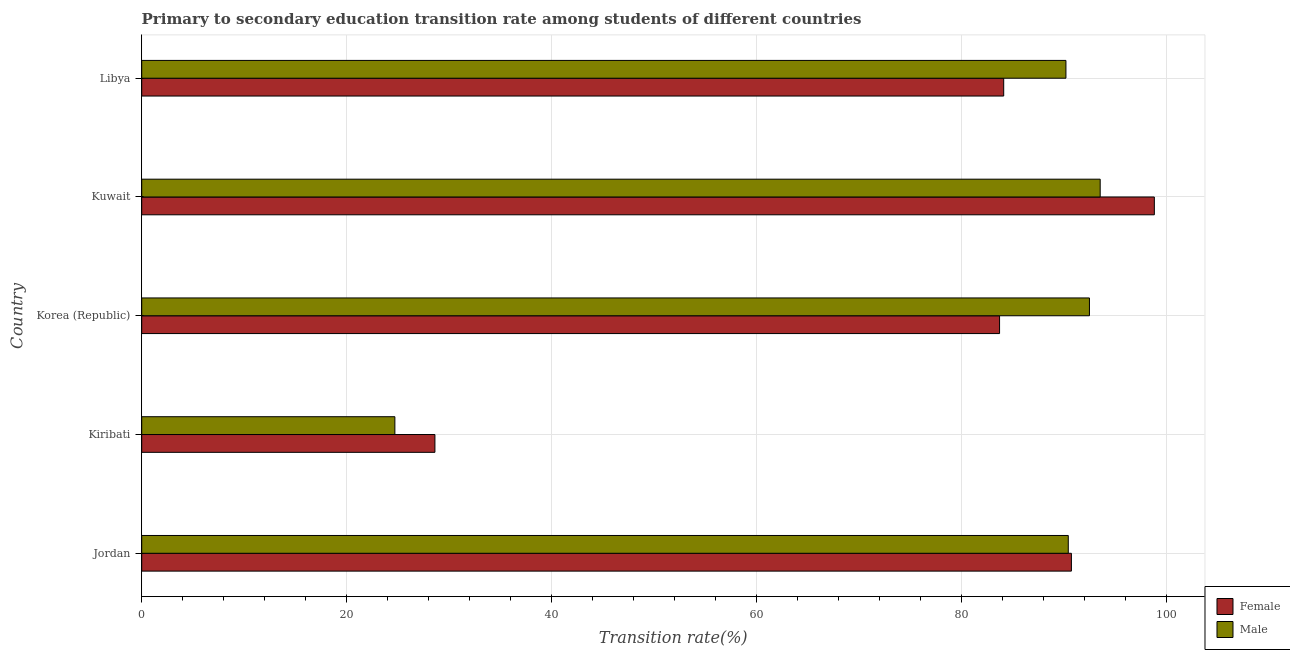How many groups of bars are there?
Make the answer very short. 5. How many bars are there on the 2nd tick from the top?
Offer a very short reply. 2. How many bars are there on the 3rd tick from the bottom?
Your response must be concise. 2. What is the label of the 1st group of bars from the top?
Give a very brief answer. Libya. In how many cases, is the number of bars for a given country not equal to the number of legend labels?
Offer a very short reply. 0. What is the transition rate among female students in Kuwait?
Offer a very short reply. 98.77. Across all countries, what is the maximum transition rate among female students?
Provide a succinct answer. 98.77. Across all countries, what is the minimum transition rate among female students?
Your answer should be compact. 28.6. In which country was the transition rate among female students maximum?
Give a very brief answer. Kuwait. In which country was the transition rate among male students minimum?
Ensure brevity in your answer.  Kiribati. What is the total transition rate among female students in the graph?
Your response must be concise. 385.8. What is the difference between the transition rate among female students in Kuwait and that in Libya?
Provide a short and direct response. 14.69. What is the difference between the transition rate among male students in Libya and the transition rate among female students in Jordan?
Keep it short and to the point. -0.53. What is the average transition rate among female students per country?
Your response must be concise. 77.16. What is the difference between the transition rate among female students and transition rate among male students in Kiribati?
Make the answer very short. 3.91. Is the difference between the transition rate among female students in Jordan and Korea (Republic) greater than the difference between the transition rate among male students in Jordan and Korea (Republic)?
Provide a short and direct response. Yes. What is the difference between the highest and the second highest transition rate among female students?
Keep it short and to the point. 8.09. What is the difference between the highest and the lowest transition rate among male students?
Ensure brevity in your answer.  68.8. How many countries are there in the graph?
Your answer should be compact. 5. What is the difference between two consecutive major ticks on the X-axis?
Your answer should be very brief. 20. Are the values on the major ticks of X-axis written in scientific E-notation?
Provide a succinct answer. No. Where does the legend appear in the graph?
Offer a terse response. Bottom right. How many legend labels are there?
Make the answer very short. 2. What is the title of the graph?
Give a very brief answer. Primary to secondary education transition rate among students of different countries. Does "Under-five" appear as one of the legend labels in the graph?
Keep it short and to the point. No. What is the label or title of the X-axis?
Provide a succinct answer. Transition rate(%). What is the Transition rate(%) of Female in Jordan?
Your answer should be compact. 90.68. What is the Transition rate(%) in Male in Jordan?
Your answer should be very brief. 90.37. What is the Transition rate(%) of Female in Kiribati?
Make the answer very short. 28.6. What is the Transition rate(%) of Male in Kiribati?
Keep it short and to the point. 24.69. What is the Transition rate(%) in Female in Korea (Republic)?
Make the answer very short. 83.67. What is the Transition rate(%) of Male in Korea (Republic)?
Offer a very short reply. 92.44. What is the Transition rate(%) in Female in Kuwait?
Provide a succinct answer. 98.77. What is the Transition rate(%) of Male in Kuwait?
Ensure brevity in your answer.  93.49. What is the Transition rate(%) of Female in Libya?
Your response must be concise. 84.08. What is the Transition rate(%) in Male in Libya?
Offer a very short reply. 90.15. Across all countries, what is the maximum Transition rate(%) in Female?
Ensure brevity in your answer.  98.77. Across all countries, what is the maximum Transition rate(%) in Male?
Your response must be concise. 93.49. Across all countries, what is the minimum Transition rate(%) in Female?
Your response must be concise. 28.6. Across all countries, what is the minimum Transition rate(%) in Male?
Your answer should be very brief. 24.69. What is the total Transition rate(%) of Female in the graph?
Give a very brief answer. 385.8. What is the total Transition rate(%) in Male in the graph?
Your answer should be very brief. 391.14. What is the difference between the Transition rate(%) in Female in Jordan and that in Kiribati?
Offer a very short reply. 62.08. What is the difference between the Transition rate(%) of Male in Jordan and that in Kiribati?
Your response must be concise. 65.68. What is the difference between the Transition rate(%) in Female in Jordan and that in Korea (Republic)?
Give a very brief answer. 7.01. What is the difference between the Transition rate(%) of Male in Jordan and that in Korea (Republic)?
Give a very brief answer. -2.07. What is the difference between the Transition rate(%) of Female in Jordan and that in Kuwait?
Your answer should be very brief. -8.09. What is the difference between the Transition rate(%) in Male in Jordan and that in Kuwait?
Offer a terse response. -3.11. What is the difference between the Transition rate(%) in Female in Jordan and that in Libya?
Your answer should be very brief. 6.6. What is the difference between the Transition rate(%) of Male in Jordan and that in Libya?
Ensure brevity in your answer.  0.23. What is the difference between the Transition rate(%) of Female in Kiribati and that in Korea (Republic)?
Offer a very short reply. -55.07. What is the difference between the Transition rate(%) in Male in Kiribati and that in Korea (Republic)?
Provide a short and direct response. -67.75. What is the difference between the Transition rate(%) of Female in Kiribati and that in Kuwait?
Keep it short and to the point. -70.17. What is the difference between the Transition rate(%) of Male in Kiribati and that in Kuwait?
Ensure brevity in your answer.  -68.8. What is the difference between the Transition rate(%) in Female in Kiribati and that in Libya?
Your answer should be compact. -55.48. What is the difference between the Transition rate(%) of Male in Kiribati and that in Libya?
Provide a short and direct response. -65.45. What is the difference between the Transition rate(%) in Female in Korea (Republic) and that in Kuwait?
Offer a very short reply. -15.1. What is the difference between the Transition rate(%) in Male in Korea (Republic) and that in Kuwait?
Ensure brevity in your answer.  -1.05. What is the difference between the Transition rate(%) of Female in Korea (Republic) and that in Libya?
Make the answer very short. -0.4. What is the difference between the Transition rate(%) of Male in Korea (Republic) and that in Libya?
Give a very brief answer. 2.29. What is the difference between the Transition rate(%) in Female in Kuwait and that in Libya?
Offer a terse response. 14.69. What is the difference between the Transition rate(%) in Male in Kuwait and that in Libya?
Ensure brevity in your answer.  3.34. What is the difference between the Transition rate(%) of Female in Jordan and the Transition rate(%) of Male in Kiribati?
Give a very brief answer. 65.99. What is the difference between the Transition rate(%) of Female in Jordan and the Transition rate(%) of Male in Korea (Republic)?
Provide a succinct answer. -1.76. What is the difference between the Transition rate(%) in Female in Jordan and the Transition rate(%) in Male in Kuwait?
Offer a terse response. -2.81. What is the difference between the Transition rate(%) in Female in Jordan and the Transition rate(%) in Male in Libya?
Make the answer very short. 0.53. What is the difference between the Transition rate(%) of Female in Kiribati and the Transition rate(%) of Male in Korea (Republic)?
Keep it short and to the point. -63.84. What is the difference between the Transition rate(%) of Female in Kiribati and the Transition rate(%) of Male in Kuwait?
Offer a terse response. -64.89. What is the difference between the Transition rate(%) in Female in Kiribati and the Transition rate(%) in Male in Libya?
Your response must be concise. -61.55. What is the difference between the Transition rate(%) of Female in Korea (Republic) and the Transition rate(%) of Male in Kuwait?
Ensure brevity in your answer.  -9.81. What is the difference between the Transition rate(%) of Female in Korea (Republic) and the Transition rate(%) of Male in Libya?
Provide a short and direct response. -6.47. What is the difference between the Transition rate(%) of Female in Kuwait and the Transition rate(%) of Male in Libya?
Your answer should be very brief. 8.62. What is the average Transition rate(%) in Female per country?
Provide a succinct answer. 77.16. What is the average Transition rate(%) of Male per country?
Your response must be concise. 78.23. What is the difference between the Transition rate(%) of Female and Transition rate(%) of Male in Jordan?
Your response must be concise. 0.31. What is the difference between the Transition rate(%) of Female and Transition rate(%) of Male in Kiribati?
Provide a succinct answer. 3.91. What is the difference between the Transition rate(%) in Female and Transition rate(%) in Male in Korea (Republic)?
Offer a terse response. -8.77. What is the difference between the Transition rate(%) of Female and Transition rate(%) of Male in Kuwait?
Keep it short and to the point. 5.28. What is the difference between the Transition rate(%) in Female and Transition rate(%) in Male in Libya?
Provide a short and direct response. -6.07. What is the ratio of the Transition rate(%) in Female in Jordan to that in Kiribati?
Make the answer very short. 3.17. What is the ratio of the Transition rate(%) in Male in Jordan to that in Kiribati?
Your answer should be compact. 3.66. What is the ratio of the Transition rate(%) in Female in Jordan to that in Korea (Republic)?
Offer a very short reply. 1.08. What is the ratio of the Transition rate(%) in Male in Jordan to that in Korea (Republic)?
Keep it short and to the point. 0.98. What is the ratio of the Transition rate(%) in Female in Jordan to that in Kuwait?
Your response must be concise. 0.92. What is the ratio of the Transition rate(%) of Male in Jordan to that in Kuwait?
Keep it short and to the point. 0.97. What is the ratio of the Transition rate(%) in Female in Jordan to that in Libya?
Keep it short and to the point. 1.08. What is the ratio of the Transition rate(%) in Male in Jordan to that in Libya?
Your answer should be very brief. 1. What is the ratio of the Transition rate(%) of Female in Kiribati to that in Korea (Republic)?
Your answer should be compact. 0.34. What is the ratio of the Transition rate(%) in Male in Kiribati to that in Korea (Republic)?
Provide a short and direct response. 0.27. What is the ratio of the Transition rate(%) in Female in Kiribati to that in Kuwait?
Your response must be concise. 0.29. What is the ratio of the Transition rate(%) of Male in Kiribati to that in Kuwait?
Your response must be concise. 0.26. What is the ratio of the Transition rate(%) of Female in Kiribati to that in Libya?
Offer a very short reply. 0.34. What is the ratio of the Transition rate(%) in Male in Kiribati to that in Libya?
Offer a very short reply. 0.27. What is the ratio of the Transition rate(%) in Female in Korea (Republic) to that in Kuwait?
Offer a very short reply. 0.85. What is the ratio of the Transition rate(%) in Male in Korea (Republic) to that in Kuwait?
Give a very brief answer. 0.99. What is the ratio of the Transition rate(%) of Male in Korea (Republic) to that in Libya?
Your answer should be very brief. 1.03. What is the ratio of the Transition rate(%) of Female in Kuwait to that in Libya?
Give a very brief answer. 1.17. What is the ratio of the Transition rate(%) of Male in Kuwait to that in Libya?
Provide a succinct answer. 1.04. What is the difference between the highest and the second highest Transition rate(%) of Female?
Make the answer very short. 8.09. What is the difference between the highest and the second highest Transition rate(%) of Male?
Offer a very short reply. 1.05. What is the difference between the highest and the lowest Transition rate(%) in Female?
Your response must be concise. 70.17. What is the difference between the highest and the lowest Transition rate(%) in Male?
Provide a short and direct response. 68.8. 